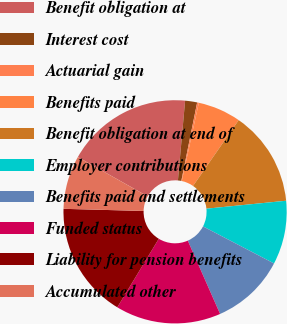<chart> <loc_0><loc_0><loc_500><loc_500><pie_chart><fcel>Benefit obligation at<fcel>Interest cost<fcel>Actuarial gain<fcel>Benefits paid<fcel>Benefit obligation at end of<fcel>Employer contributions<fcel>Benefits paid and settlements<fcel>Funded status<fcel>Liability for pension benefits<fcel>Accumulated other<nl><fcel>18.27%<fcel>1.74%<fcel>0.24%<fcel>6.24%<fcel>13.77%<fcel>9.24%<fcel>10.74%<fcel>15.27%<fcel>16.77%<fcel>7.74%<nl></chart> 